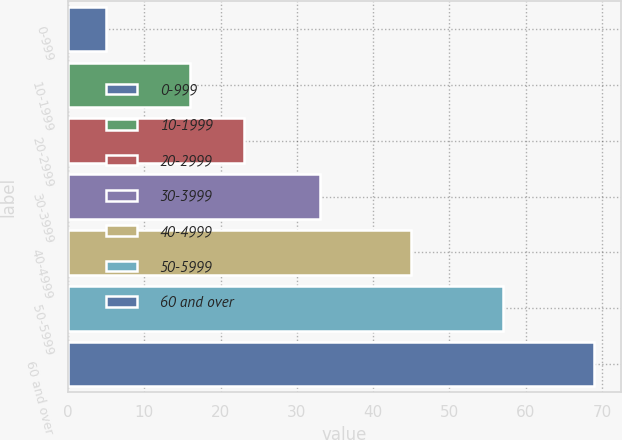Convert chart to OTSL. <chart><loc_0><loc_0><loc_500><loc_500><bar_chart><fcel>0-999<fcel>10-1999<fcel>20-2999<fcel>30-3999<fcel>40-4999<fcel>50-5999<fcel>60 and over<nl><fcel>5<fcel>16<fcel>23<fcel>33<fcel>45<fcel>57<fcel>69<nl></chart> 